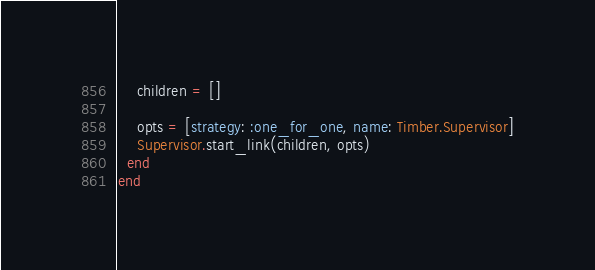Convert code to text. <code><loc_0><loc_0><loc_500><loc_500><_Elixir_>    children = []

    opts = [strategy: :one_for_one, name: Timber.Supervisor]
    Supervisor.start_link(children, opts)
  end
end
</code> 